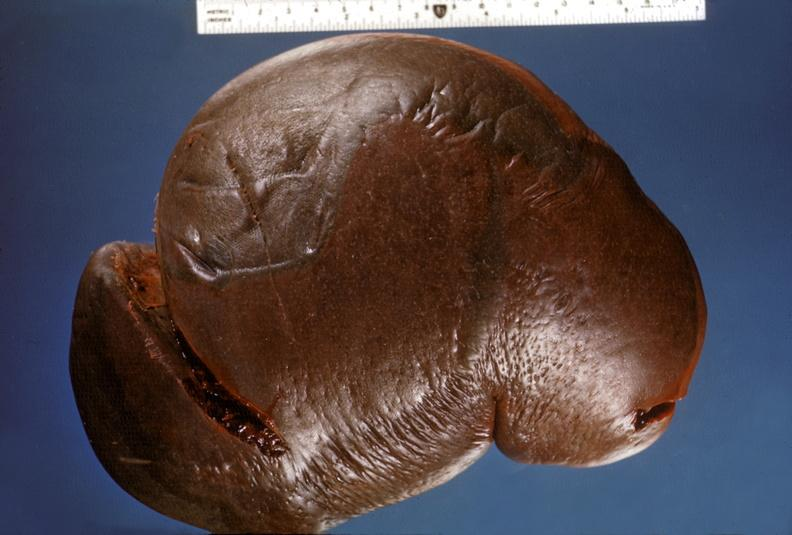does this image show spleen, hypersplenism?
Answer the question using a single word or phrase. Yes 